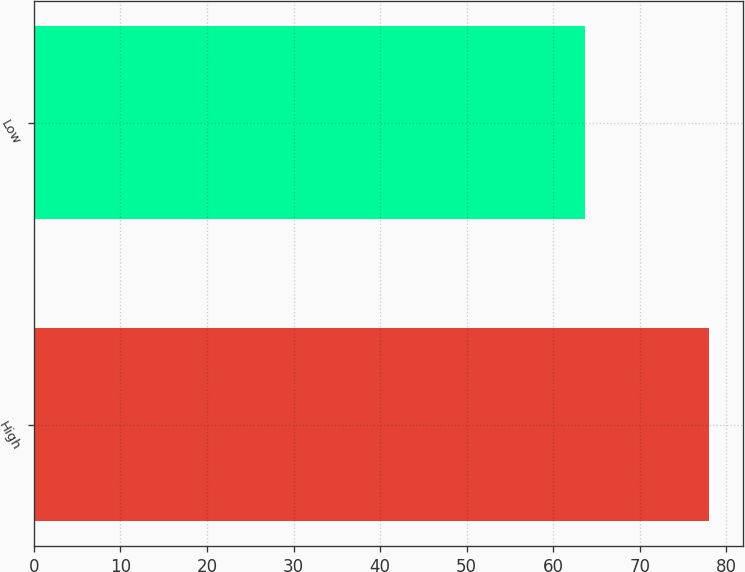<chart> <loc_0><loc_0><loc_500><loc_500><bar_chart><fcel>High<fcel>Low<nl><fcel>77.98<fcel>63.69<nl></chart> 